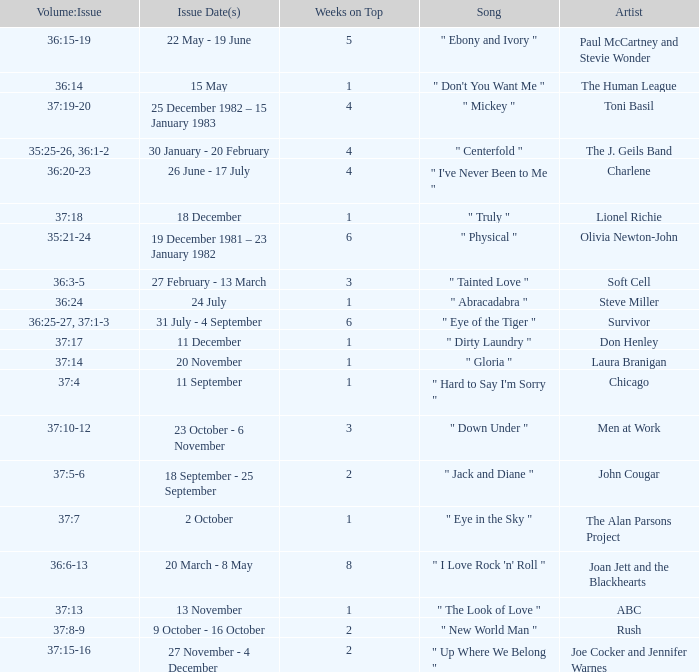Which release date(s) has weeks on top greater than 3, and a volume: issue of 35:25-26, 36:1-2? 30 January - 20 February. 